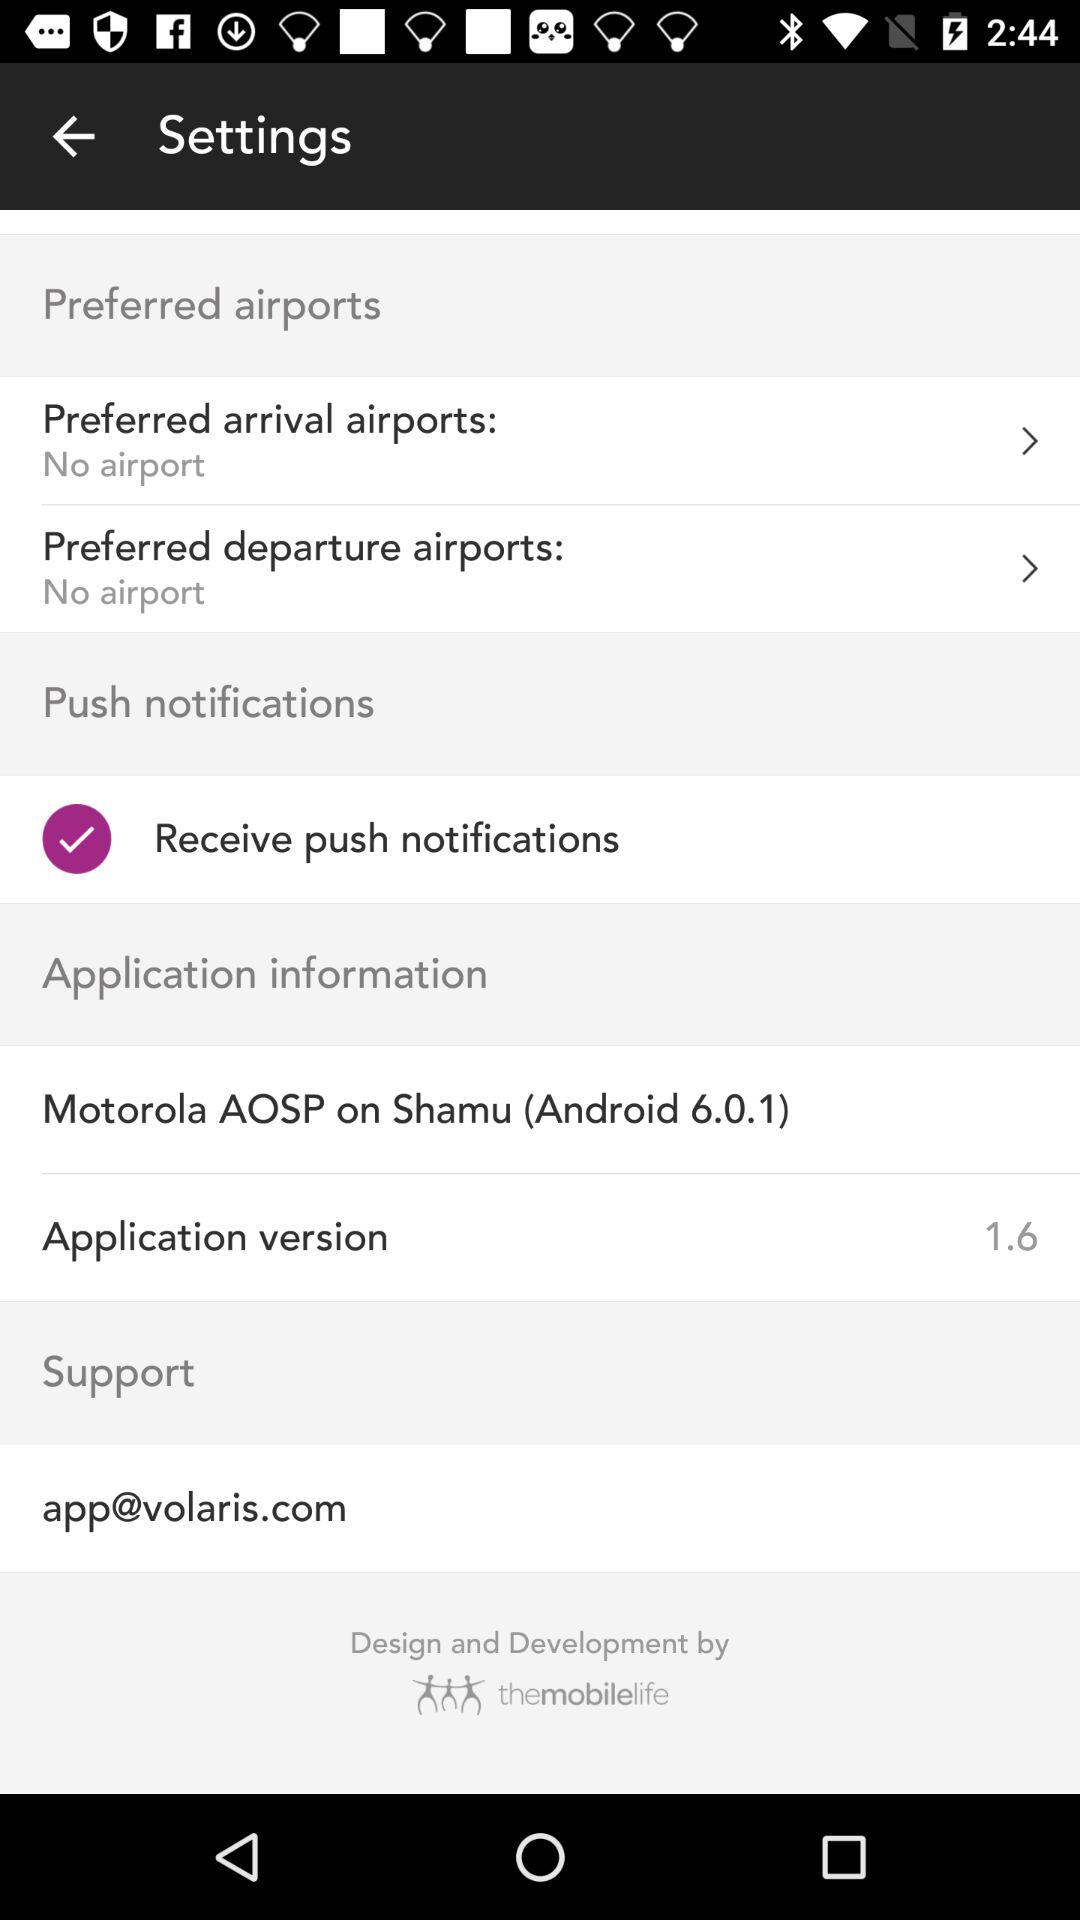How many push notification options are available?
Answer the question using a single word or phrase. 1 